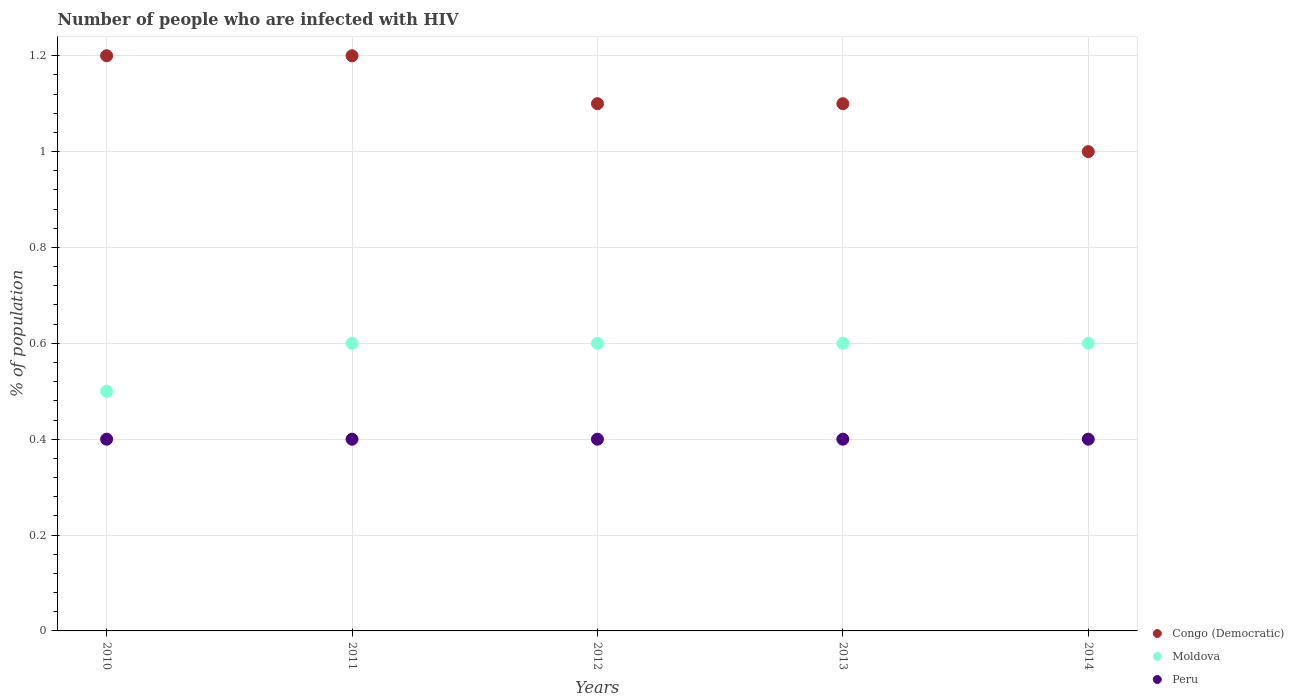How many different coloured dotlines are there?
Provide a short and direct response. 3. Is the number of dotlines equal to the number of legend labels?
Offer a terse response. Yes. In which year was the percentage of HIV infected population in in Congo (Democratic) maximum?
Ensure brevity in your answer.  2010. In which year was the percentage of HIV infected population in in Moldova minimum?
Ensure brevity in your answer.  2010. What is the total percentage of HIV infected population in in Peru in the graph?
Give a very brief answer. 2. What is the difference between the percentage of HIV infected population in in Peru in 2010 and that in 2014?
Provide a short and direct response. 0. What is the difference between the percentage of HIV infected population in in Peru in 2014 and the percentage of HIV infected population in in Moldova in 2010?
Ensure brevity in your answer.  -0.1. What is the average percentage of HIV infected population in in Congo (Democratic) per year?
Provide a succinct answer. 1.12. In the year 2011, what is the difference between the percentage of HIV infected population in in Peru and percentage of HIV infected population in in Moldova?
Your answer should be very brief. -0.2. In how many years, is the percentage of HIV infected population in in Peru greater than 0.52 %?
Make the answer very short. 0. Is the percentage of HIV infected population in in Peru in 2011 less than that in 2014?
Keep it short and to the point. No. Is the difference between the percentage of HIV infected population in in Peru in 2010 and 2011 greater than the difference between the percentage of HIV infected population in in Moldova in 2010 and 2011?
Give a very brief answer. Yes. What is the difference between the highest and the second highest percentage of HIV infected population in in Congo (Democratic)?
Your answer should be compact. 0. In how many years, is the percentage of HIV infected population in in Moldova greater than the average percentage of HIV infected population in in Moldova taken over all years?
Keep it short and to the point. 4. Is it the case that in every year, the sum of the percentage of HIV infected population in in Moldova and percentage of HIV infected population in in Congo (Democratic)  is greater than the percentage of HIV infected population in in Peru?
Ensure brevity in your answer.  Yes. Is the percentage of HIV infected population in in Peru strictly greater than the percentage of HIV infected population in in Congo (Democratic) over the years?
Your answer should be very brief. No. Are the values on the major ticks of Y-axis written in scientific E-notation?
Keep it short and to the point. No. How many legend labels are there?
Give a very brief answer. 3. How are the legend labels stacked?
Keep it short and to the point. Vertical. What is the title of the graph?
Offer a terse response. Number of people who are infected with HIV. Does "Spain" appear as one of the legend labels in the graph?
Offer a very short reply. No. What is the label or title of the Y-axis?
Your answer should be compact. % of population. What is the % of population in Congo (Democratic) in 2010?
Provide a succinct answer. 1.2. What is the % of population of Moldova in 2012?
Offer a terse response. 0.6. What is the % of population in Peru in 2012?
Make the answer very short. 0.4. What is the % of population of Congo (Democratic) in 2013?
Keep it short and to the point. 1.1. What is the % of population in Moldova in 2013?
Make the answer very short. 0.6. What is the % of population in Peru in 2013?
Offer a terse response. 0.4. Across all years, what is the maximum % of population in Congo (Democratic)?
Provide a short and direct response. 1.2. Across all years, what is the maximum % of population in Peru?
Make the answer very short. 0.4. Across all years, what is the minimum % of population of Moldova?
Your answer should be compact. 0.5. Across all years, what is the minimum % of population in Peru?
Give a very brief answer. 0.4. What is the total % of population of Peru in the graph?
Make the answer very short. 2. What is the difference between the % of population in Moldova in 2010 and that in 2011?
Your answer should be compact. -0.1. What is the difference between the % of population of Peru in 2010 and that in 2011?
Provide a succinct answer. 0. What is the difference between the % of population in Congo (Democratic) in 2010 and that in 2012?
Your response must be concise. 0.1. What is the difference between the % of population of Congo (Democratic) in 2010 and that in 2013?
Your answer should be very brief. 0.1. What is the difference between the % of population of Peru in 2010 and that in 2013?
Offer a very short reply. 0. What is the difference between the % of population in Congo (Democratic) in 2010 and that in 2014?
Give a very brief answer. 0.2. What is the difference between the % of population of Congo (Democratic) in 2011 and that in 2012?
Your response must be concise. 0.1. What is the difference between the % of population of Peru in 2011 and that in 2012?
Ensure brevity in your answer.  0. What is the difference between the % of population in Peru in 2011 and that in 2013?
Give a very brief answer. 0. What is the difference between the % of population in Congo (Democratic) in 2012 and that in 2013?
Give a very brief answer. 0. What is the difference between the % of population in Moldova in 2012 and that in 2013?
Offer a terse response. 0. What is the difference between the % of population in Congo (Democratic) in 2012 and that in 2014?
Your answer should be compact. 0.1. What is the difference between the % of population in Moldova in 2012 and that in 2014?
Provide a succinct answer. 0. What is the difference between the % of population of Peru in 2012 and that in 2014?
Make the answer very short. 0. What is the difference between the % of population in Congo (Democratic) in 2013 and that in 2014?
Your answer should be compact. 0.1. What is the difference between the % of population of Peru in 2013 and that in 2014?
Keep it short and to the point. 0. What is the difference between the % of population in Congo (Democratic) in 2010 and the % of population in Moldova in 2011?
Give a very brief answer. 0.6. What is the difference between the % of population in Moldova in 2010 and the % of population in Peru in 2011?
Make the answer very short. 0.1. What is the difference between the % of population in Congo (Democratic) in 2010 and the % of population in Moldova in 2012?
Give a very brief answer. 0.6. What is the difference between the % of population in Moldova in 2010 and the % of population in Peru in 2012?
Offer a very short reply. 0.1. What is the difference between the % of population in Congo (Democratic) in 2010 and the % of population in Moldova in 2013?
Give a very brief answer. 0.6. What is the difference between the % of population in Moldova in 2010 and the % of population in Peru in 2013?
Ensure brevity in your answer.  0.1. What is the difference between the % of population in Congo (Democratic) in 2011 and the % of population in Moldova in 2012?
Keep it short and to the point. 0.6. What is the difference between the % of population in Congo (Democratic) in 2011 and the % of population in Peru in 2012?
Provide a short and direct response. 0.8. What is the difference between the % of population of Moldova in 2011 and the % of population of Peru in 2012?
Offer a terse response. 0.2. What is the difference between the % of population of Congo (Democratic) in 2011 and the % of population of Moldova in 2013?
Offer a terse response. 0.6. What is the difference between the % of population of Congo (Democratic) in 2011 and the % of population of Peru in 2013?
Your answer should be compact. 0.8. What is the difference between the % of population in Moldova in 2011 and the % of population in Peru in 2013?
Provide a short and direct response. 0.2. What is the difference between the % of population of Congo (Democratic) in 2011 and the % of population of Peru in 2014?
Make the answer very short. 0.8. What is the difference between the % of population of Congo (Democratic) in 2012 and the % of population of Moldova in 2013?
Make the answer very short. 0.5. What is the difference between the % of population in Congo (Democratic) in 2012 and the % of population in Peru in 2013?
Keep it short and to the point. 0.7. What is the difference between the % of population in Moldova in 2012 and the % of population in Peru in 2013?
Your answer should be compact. 0.2. What is the difference between the % of population of Congo (Democratic) in 2012 and the % of population of Peru in 2014?
Make the answer very short. 0.7. What is the difference between the % of population of Moldova in 2012 and the % of population of Peru in 2014?
Ensure brevity in your answer.  0.2. What is the difference between the % of population in Congo (Democratic) in 2013 and the % of population in Moldova in 2014?
Your answer should be compact. 0.5. What is the difference between the % of population in Congo (Democratic) in 2013 and the % of population in Peru in 2014?
Provide a succinct answer. 0.7. What is the average % of population of Congo (Democratic) per year?
Make the answer very short. 1.12. What is the average % of population in Moldova per year?
Your response must be concise. 0.58. In the year 2010, what is the difference between the % of population of Congo (Democratic) and % of population of Moldova?
Give a very brief answer. 0.7. In the year 2010, what is the difference between the % of population of Congo (Democratic) and % of population of Peru?
Your response must be concise. 0.8. In the year 2011, what is the difference between the % of population in Congo (Democratic) and % of population in Moldova?
Make the answer very short. 0.6. In the year 2011, what is the difference between the % of population in Congo (Democratic) and % of population in Peru?
Offer a terse response. 0.8. In the year 2011, what is the difference between the % of population in Moldova and % of population in Peru?
Offer a terse response. 0.2. In the year 2012, what is the difference between the % of population of Congo (Democratic) and % of population of Peru?
Offer a terse response. 0.7. In the year 2012, what is the difference between the % of population of Moldova and % of population of Peru?
Keep it short and to the point. 0.2. In the year 2013, what is the difference between the % of population in Congo (Democratic) and % of population in Moldova?
Give a very brief answer. 0.5. In the year 2013, what is the difference between the % of population of Moldova and % of population of Peru?
Provide a succinct answer. 0.2. In the year 2014, what is the difference between the % of population of Congo (Democratic) and % of population of Peru?
Provide a short and direct response. 0.6. What is the ratio of the % of population in Congo (Democratic) in 2010 to that in 2011?
Give a very brief answer. 1. What is the ratio of the % of population in Moldova in 2010 to that in 2011?
Give a very brief answer. 0.83. What is the ratio of the % of population of Peru in 2010 to that in 2011?
Your answer should be compact. 1. What is the ratio of the % of population in Peru in 2010 to that in 2012?
Ensure brevity in your answer.  1. What is the ratio of the % of population in Congo (Democratic) in 2010 to that in 2013?
Your answer should be very brief. 1.09. What is the ratio of the % of population of Congo (Democratic) in 2010 to that in 2014?
Provide a short and direct response. 1.2. What is the ratio of the % of population of Moldova in 2010 to that in 2014?
Your answer should be compact. 0.83. What is the ratio of the % of population of Congo (Democratic) in 2011 to that in 2013?
Your answer should be very brief. 1.09. What is the ratio of the % of population in Moldova in 2011 to that in 2013?
Keep it short and to the point. 1. What is the ratio of the % of population of Peru in 2011 to that in 2013?
Give a very brief answer. 1. What is the ratio of the % of population of Congo (Democratic) in 2011 to that in 2014?
Your answer should be very brief. 1.2. What is the ratio of the % of population of Moldova in 2011 to that in 2014?
Give a very brief answer. 1. What is the ratio of the % of population in Peru in 2011 to that in 2014?
Your answer should be very brief. 1. What is the ratio of the % of population of Congo (Democratic) in 2012 to that in 2013?
Make the answer very short. 1. What is the ratio of the % of population in Congo (Democratic) in 2012 to that in 2014?
Ensure brevity in your answer.  1.1. What is the ratio of the % of population in Moldova in 2012 to that in 2014?
Provide a short and direct response. 1. What is the ratio of the % of population of Peru in 2012 to that in 2014?
Your response must be concise. 1. What is the ratio of the % of population of Congo (Democratic) in 2013 to that in 2014?
Your answer should be very brief. 1.1. What is the ratio of the % of population in Moldova in 2013 to that in 2014?
Give a very brief answer. 1. What is the difference between the highest and the second highest % of population in Moldova?
Your response must be concise. 0. What is the difference between the highest and the lowest % of population in Moldova?
Make the answer very short. 0.1. What is the difference between the highest and the lowest % of population in Peru?
Your answer should be very brief. 0. 